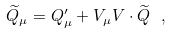Convert formula to latex. <formula><loc_0><loc_0><loc_500><loc_500>\widetilde { Q } _ { \mu } = Q ^ { \prime } _ { \mu } + V _ { \mu } V \cdot \widetilde { Q } \ ,</formula> 